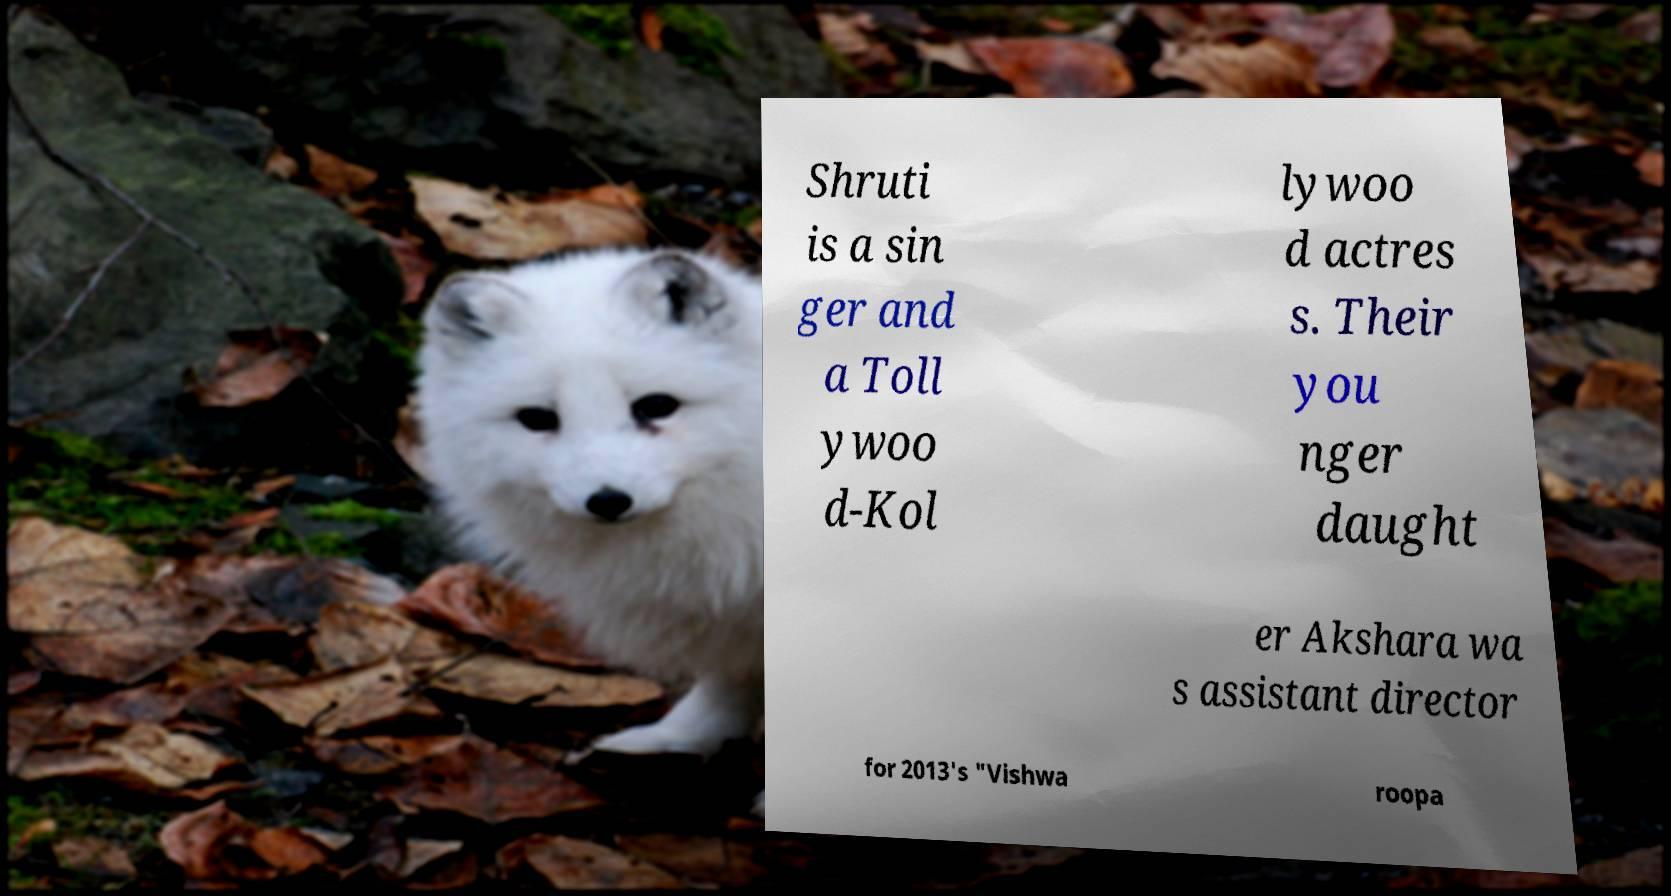I need the written content from this picture converted into text. Can you do that? Shruti is a sin ger and a Toll ywoo d-Kol lywoo d actres s. Their you nger daught er Akshara wa s assistant director for 2013's "Vishwa roopa 